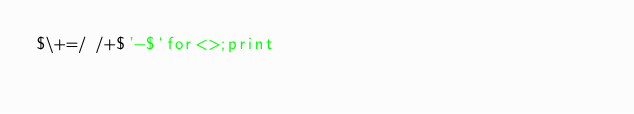<code> <loc_0><loc_0><loc_500><loc_500><_Perl_>$\+=/ /+$'-$`for<>;print</code> 